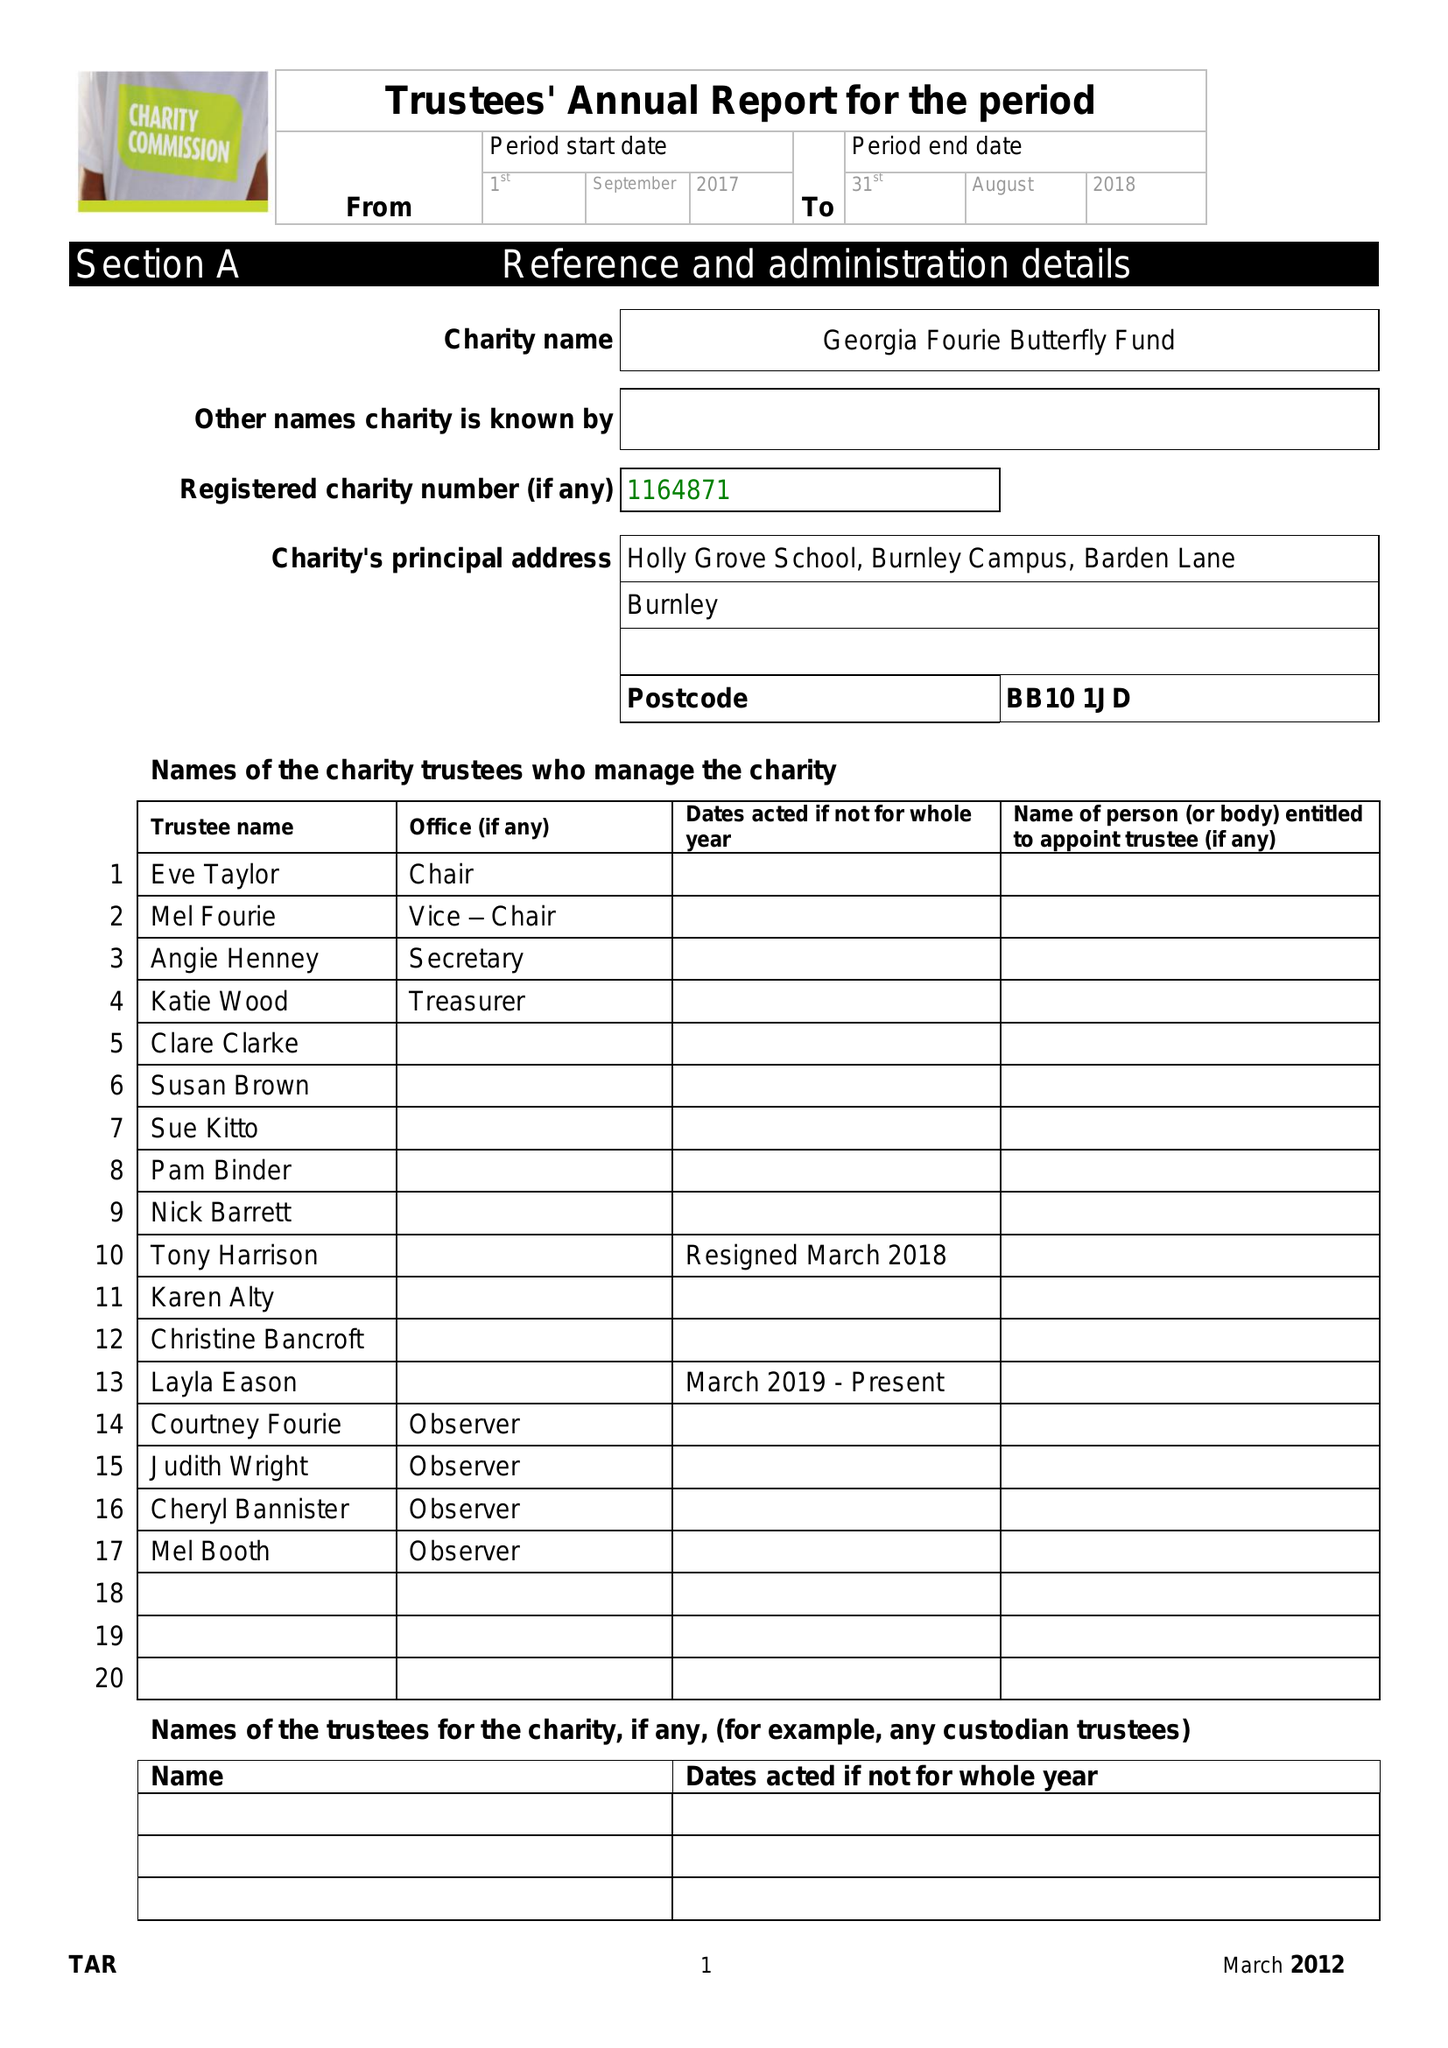What is the value for the income_annually_in_british_pounds?
Answer the question using a single word or phrase. 41975.00 